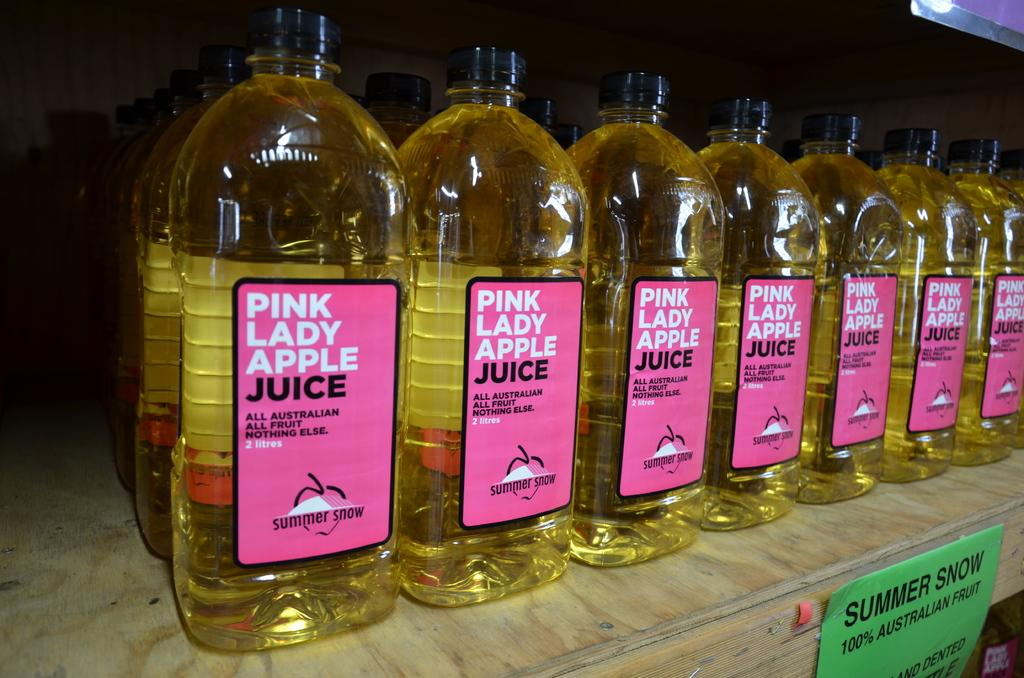<image>
Share a concise interpretation of the image provided. Several bottles of Pink Lady apple juice are lined up on a shelf. 